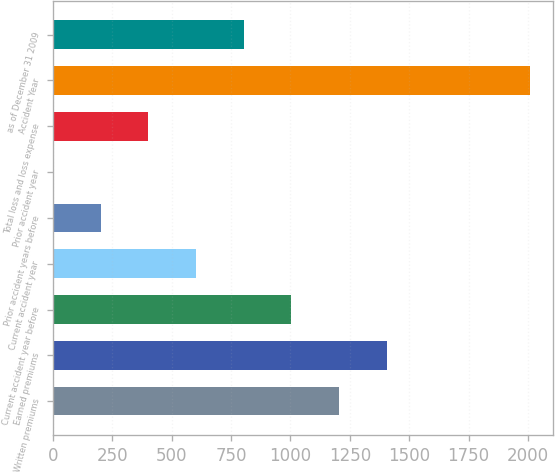Convert chart to OTSL. <chart><loc_0><loc_0><loc_500><loc_500><bar_chart><fcel>Written premiums<fcel>Earned premiums<fcel>Current accident year before<fcel>Current accident year<fcel>Prior accident years before<fcel>Prior accident year<fcel>Total loss and loss expense<fcel>Accident Year<fcel>as of December 31 2009<nl><fcel>1204.36<fcel>1405.02<fcel>1003.7<fcel>602.38<fcel>201.06<fcel>0.4<fcel>401.72<fcel>2007<fcel>803.04<nl></chart> 